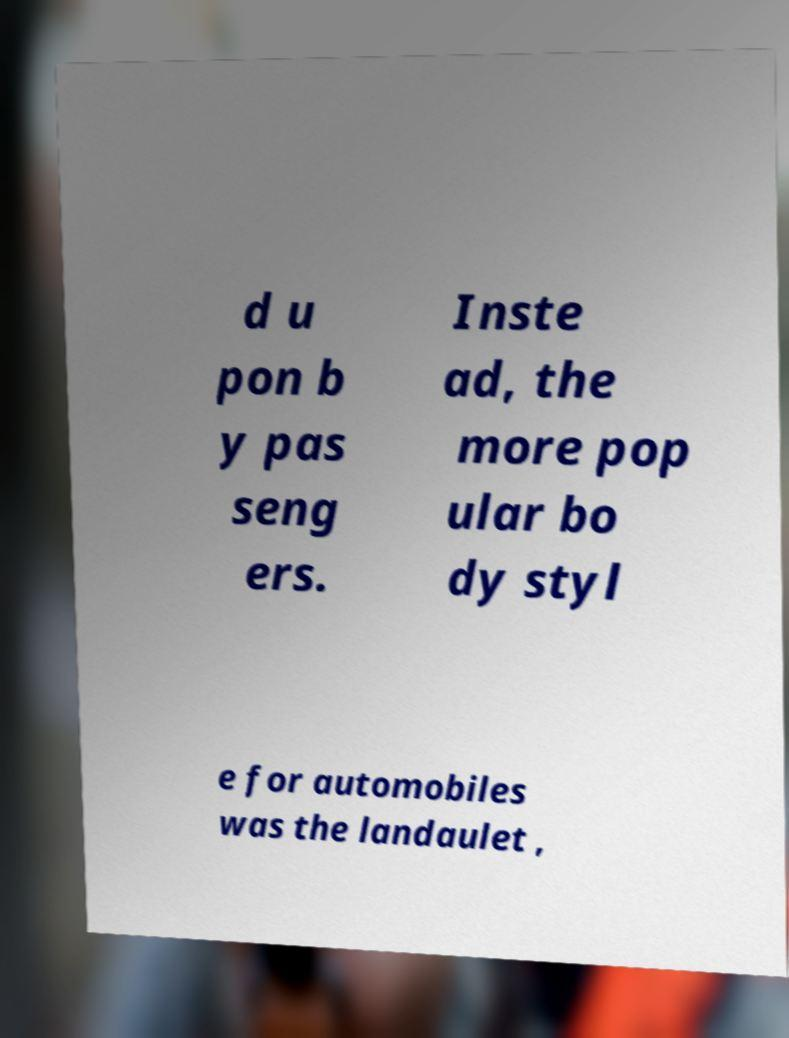Can you accurately transcribe the text from the provided image for me? d u pon b y pas seng ers. Inste ad, the more pop ular bo dy styl e for automobiles was the landaulet , 